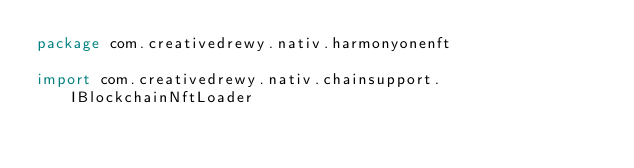Convert code to text. <code><loc_0><loc_0><loc_500><loc_500><_Kotlin_>package com.creativedrewy.nativ.harmonyonenft

import com.creativedrewy.nativ.chainsupport.IBlockchainNftLoader</code> 